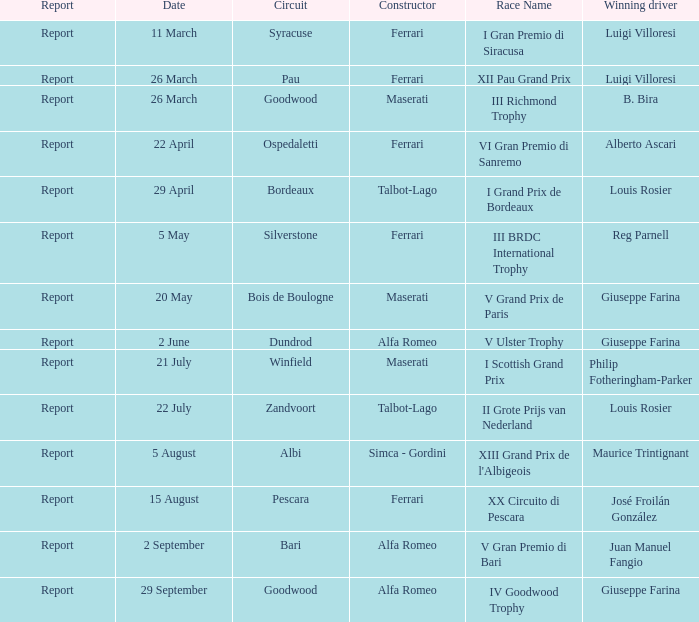Name the date for pescara 15 August. 